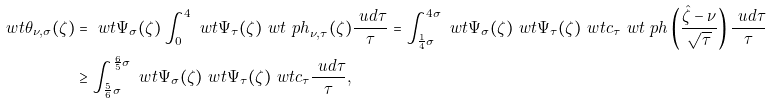Convert formula to latex. <formula><loc_0><loc_0><loc_500><loc_500>\ w t { \theta } _ { \nu , \sigma } ( \zeta ) & = \ w t { \Psi } _ { \sigma } ( \zeta ) \int _ { 0 } ^ { 4 } \ w t { \Psi } _ { \tau } ( \zeta ) \ w t { \ p h } _ { \nu , \tau } ( \zeta ) \frac { \ u d \tau } { \tau } = \int _ { \frac { 1 } { 4 } \sigma } ^ { 4 \sigma } \ w t { \Psi } _ { \sigma } ( \zeta ) \ w t { \Psi } _ { \tau } ( \zeta ) \ w t { c } _ { \tau } \ w t { \ p h } \left ( \frac { \hat { \zeta } - \nu } { \sqrt { \tau } } \right ) \frac { \ u d \tau } { \tau } \\ & \geq \int _ { \frac { 5 } { 6 } \sigma } ^ { \frac { 6 } { 5 } \sigma } \ w t { \Psi } _ { \sigma } ( \zeta ) \ w t { \Psi } _ { \tau } ( \zeta ) \ w t { c } _ { \tau } \frac { \ u d \tau } { \tau } ,</formula> 